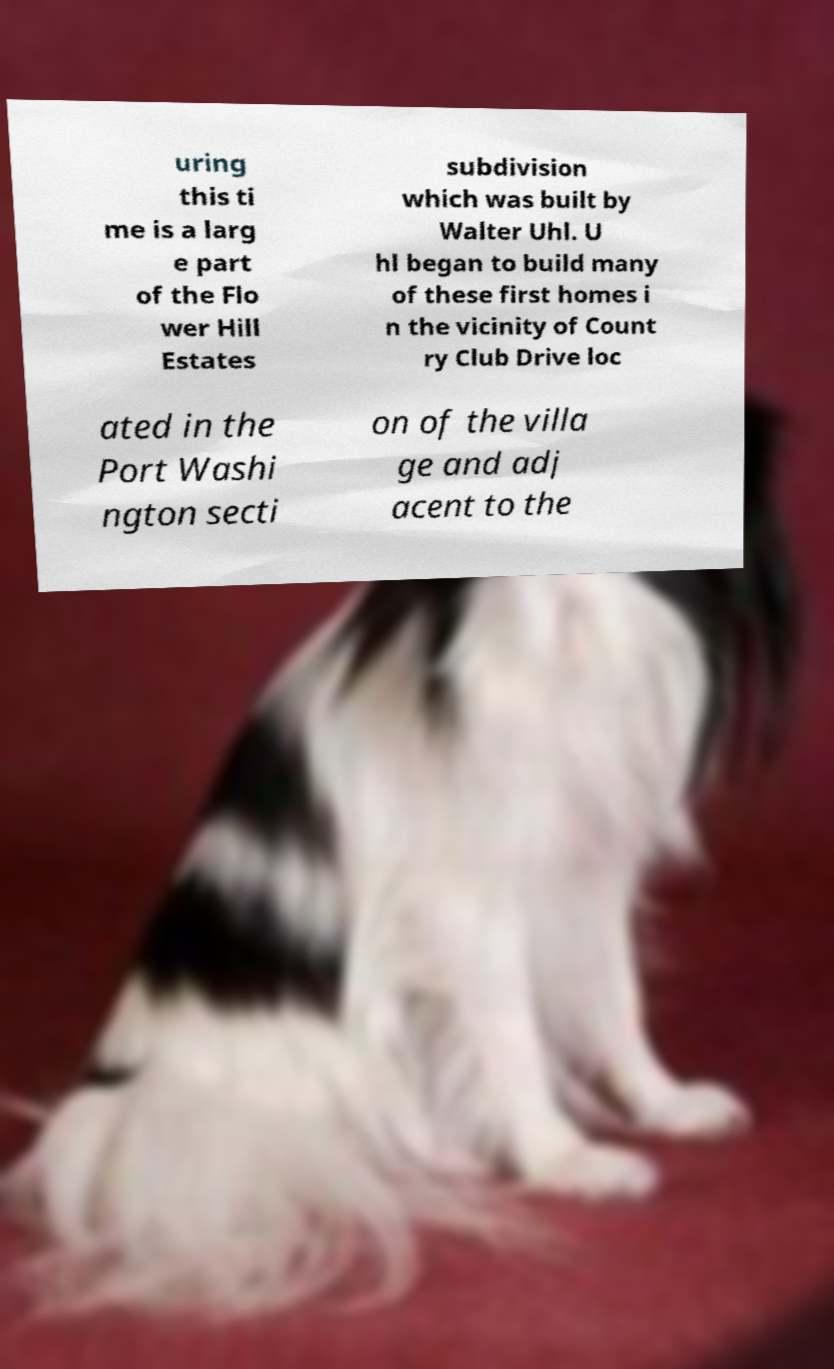For documentation purposes, I need the text within this image transcribed. Could you provide that? uring this ti me is a larg e part of the Flo wer Hill Estates subdivision which was built by Walter Uhl. U hl began to build many of these first homes i n the vicinity of Count ry Club Drive loc ated in the Port Washi ngton secti on of the villa ge and adj acent to the 